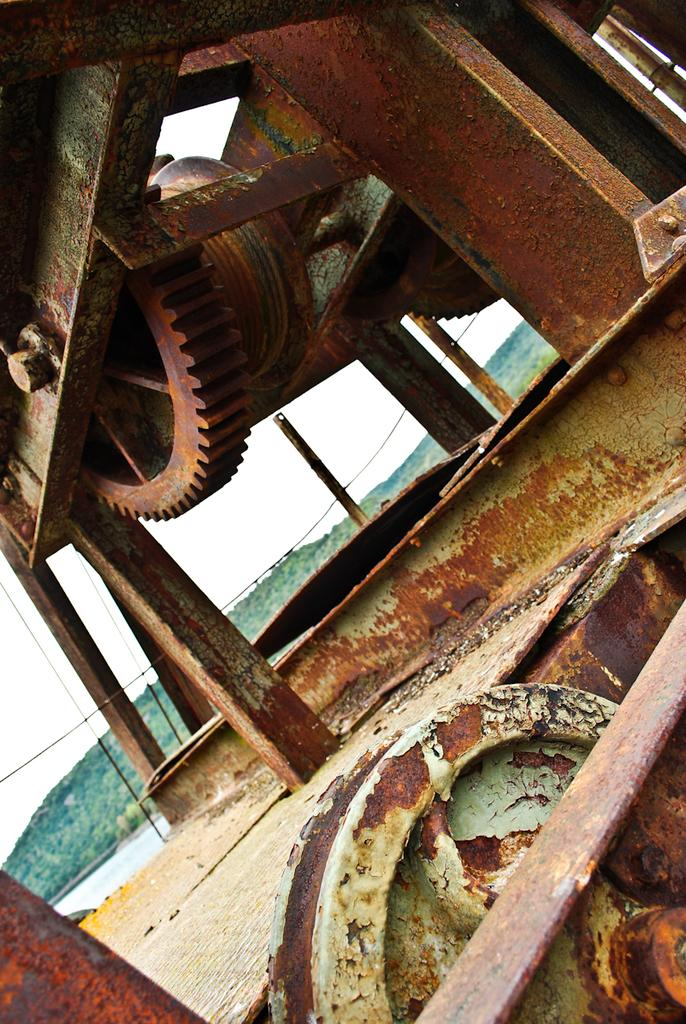What type of material is the object in the image made of? The object in the image is made of metal. Can you describe the condition of the metal object? The metal object appears to be rusty. What type of landscape feature can be seen in the image? There is a hill visible in the image. What is visible in the background of the image? The sky is visible in the image. How many fowl are perched on the rusty metal object in the image? There are no fowl present in the image, and the rusty metal object is not depicted as a perch for any animals. 